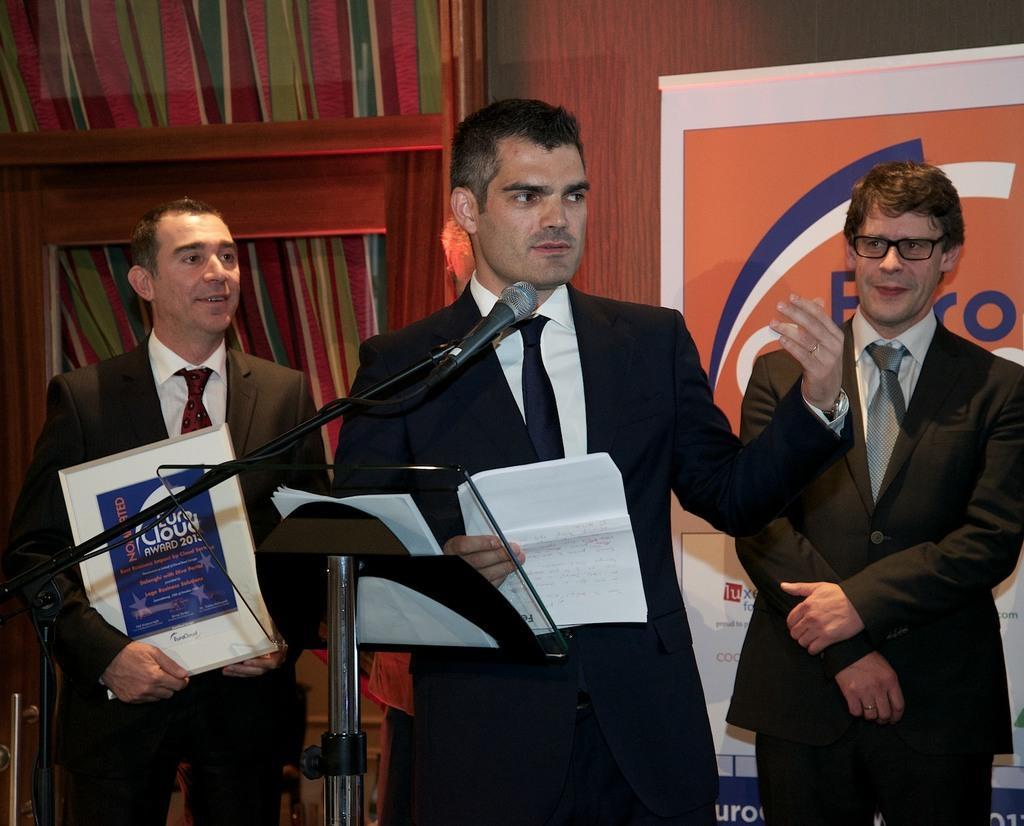How would you summarize this image in a sentence or two? In this image there are three people. There is a mike. There is wooden background. 